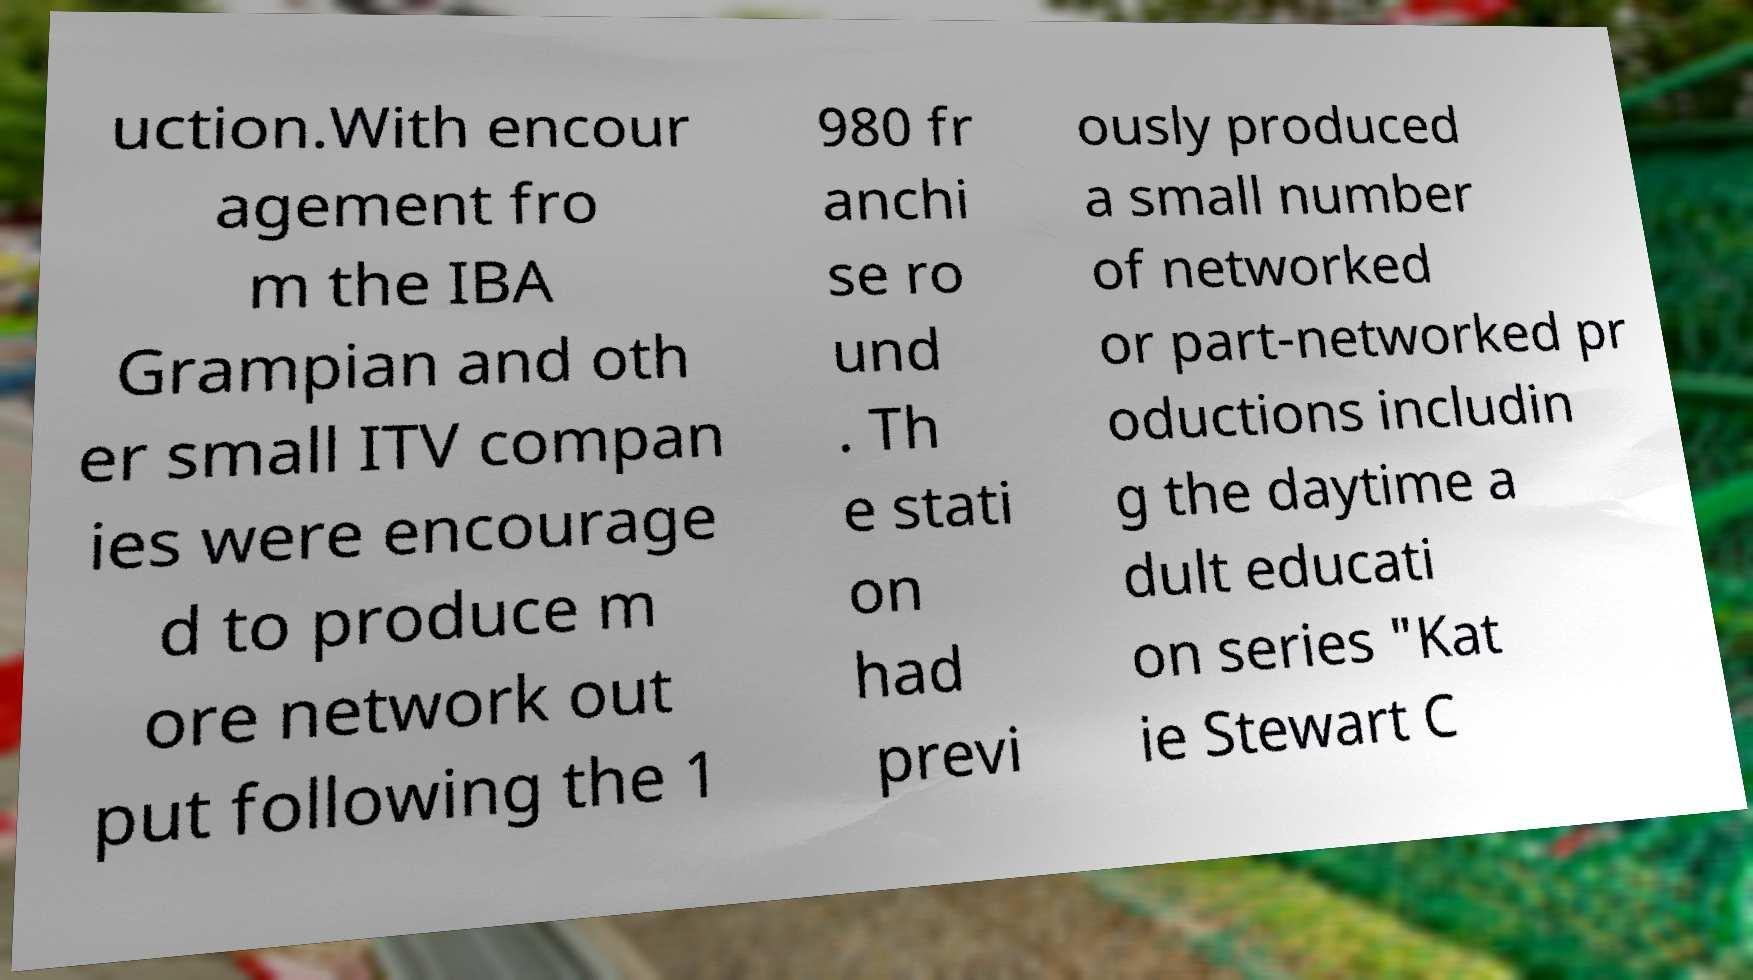Please identify and transcribe the text found in this image. uction.With encour agement fro m the IBA Grampian and oth er small ITV compan ies were encourage d to produce m ore network out put following the 1 980 fr anchi se ro und . Th e stati on had previ ously produced a small number of networked or part-networked pr oductions includin g the daytime a dult educati on series "Kat ie Stewart C 